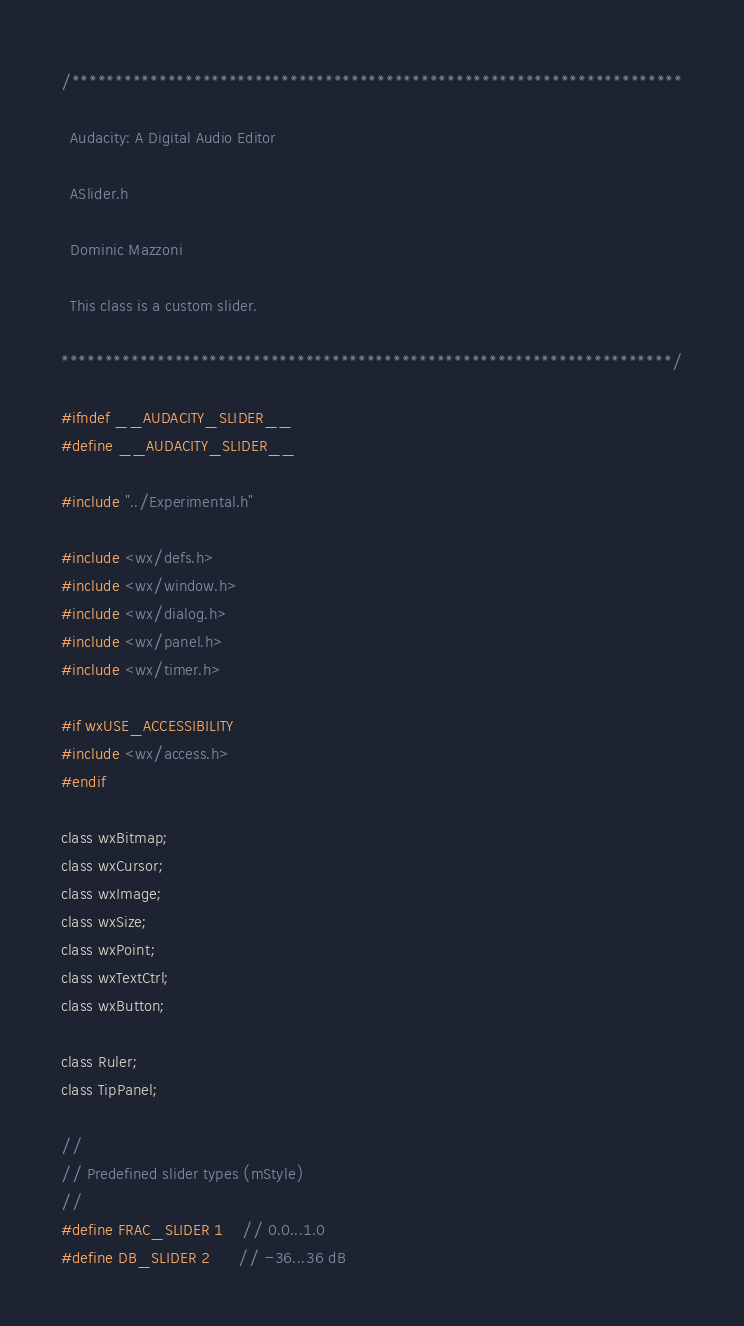Convert code to text. <code><loc_0><loc_0><loc_500><loc_500><_C_>/**********************************************************************

  Audacity: A Digital Audio Editor

  ASlider.h

  Dominic Mazzoni

  This class is a custom slider.

**********************************************************************/

#ifndef __AUDACITY_SLIDER__
#define __AUDACITY_SLIDER__

#include "../Experimental.h"

#include <wx/defs.h>
#include <wx/window.h>
#include <wx/dialog.h>
#include <wx/panel.h>
#include <wx/timer.h>

#if wxUSE_ACCESSIBILITY
#include <wx/access.h>
#endif

class wxBitmap;
class wxCursor;
class wxImage;
class wxSize;
class wxPoint;
class wxTextCtrl;
class wxButton;

class Ruler;
class TipPanel;

//
// Predefined slider types (mStyle)
//
#define FRAC_SLIDER 1    // 0.0...1.0
#define DB_SLIDER 2      // -36...36 dB</code> 